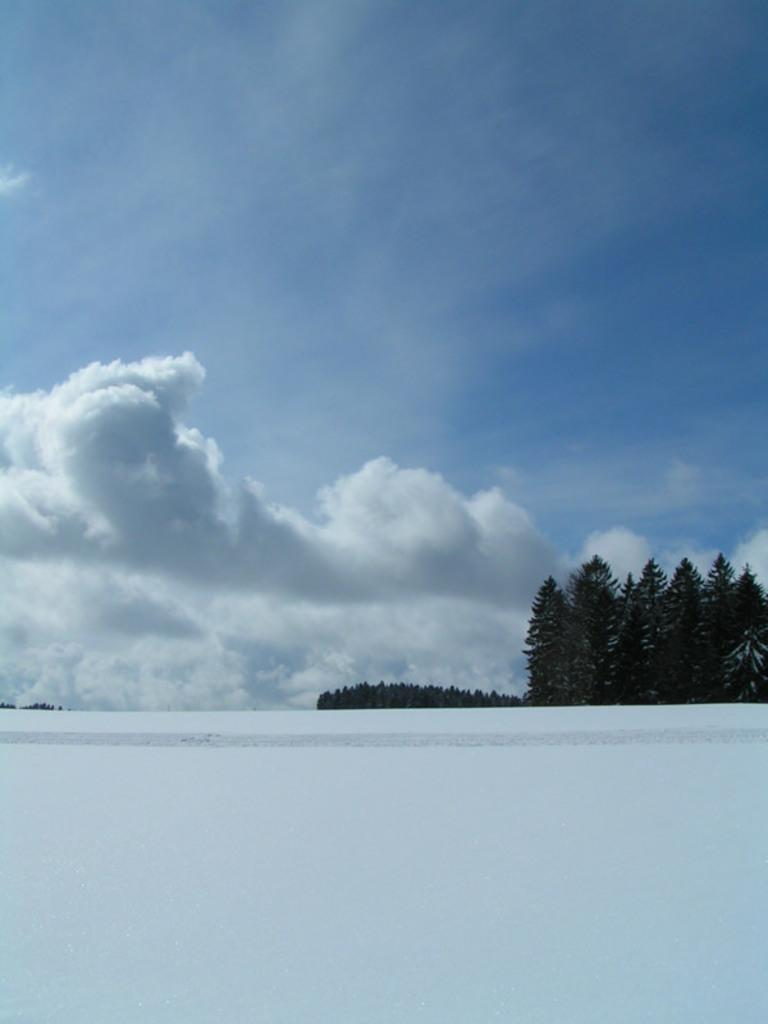What type of weather is depicted in the image? The presence of snow at the bottom of the image suggests a winter scene. What can be seen in the background of the image? There are trees in the background of the image. What else is visible in the sky besides the trees? There are clouds visible in the image. What is visible at the top of the image? The sky is visible at the top of the image. How many dimes can be seen scattered on the snow in the image? There are no dimes visible in the image; it only shows snow, trees, clouds, and the sky. What season is it in the image, considering the presence of snow? The presence of snow suggests that it is winter in the image. 